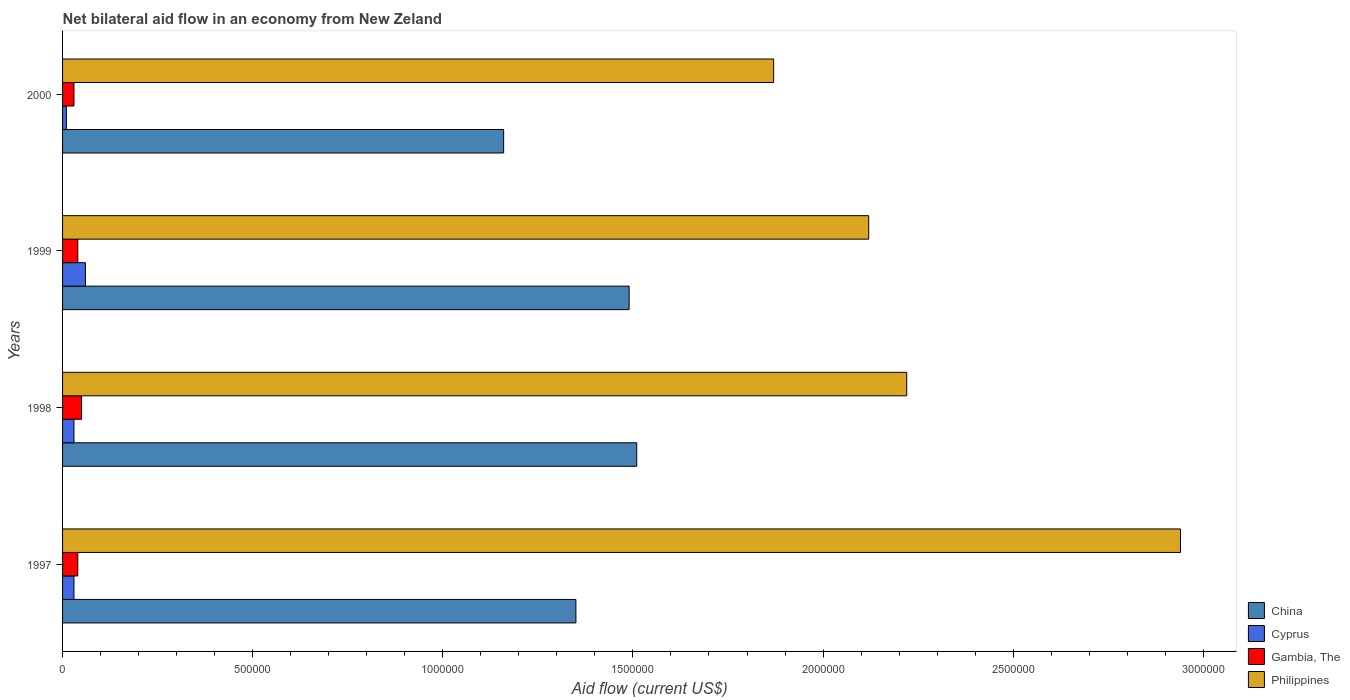How many different coloured bars are there?
Provide a short and direct response. 4. Are the number of bars per tick equal to the number of legend labels?
Your response must be concise. Yes. How many bars are there on the 1st tick from the bottom?
Make the answer very short. 4. What is the net bilateral aid flow in Philippines in 1997?
Keep it short and to the point. 2.94e+06. Across all years, what is the maximum net bilateral aid flow in China?
Offer a very short reply. 1.51e+06. In which year was the net bilateral aid flow in Philippines maximum?
Offer a terse response. 1997. What is the total net bilateral aid flow in China in the graph?
Keep it short and to the point. 5.51e+06. What is the difference between the net bilateral aid flow in Cyprus in 1997 and that in 1998?
Keep it short and to the point. 0. What is the difference between the net bilateral aid flow in China in 1998 and the net bilateral aid flow in Philippines in 1999?
Provide a succinct answer. -6.10e+05. What is the average net bilateral aid flow in Cyprus per year?
Ensure brevity in your answer.  3.25e+04. In the year 1998, what is the difference between the net bilateral aid flow in China and net bilateral aid flow in Gambia, The?
Your answer should be compact. 1.46e+06. What is the ratio of the net bilateral aid flow in Philippines in 1997 to that in 1998?
Offer a terse response. 1.32. Is the net bilateral aid flow in China in 1997 less than that in 1999?
Offer a very short reply. Yes. What is the difference between the highest and the second highest net bilateral aid flow in Gambia, The?
Ensure brevity in your answer.  10000. Is it the case that in every year, the sum of the net bilateral aid flow in Philippines and net bilateral aid flow in China is greater than the sum of net bilateral aid flow in Gambia, The and net bilateral aid flow in Cyprus?
Provide a succinct answer. Yes. What does the 4th bar from the bottom in 1999 represents?
Offer a terse response. Philippines. How many bars are there?
Offer a terse response. 16. How many years are there in the graph?
Your answer should be very brief. 4. Does the graph contain any zero values?
Provide a short and direct response. No. How many legend labels are there?
Provide a succinct answer. 4. What is the title of the graph?
Provide a short and direct response. Net bilateral aid flow in an economy from New Zeland. Does "Ethiopia" appear as one of the legend labels in the graph?
Offer a very short reply. No. What is the label or title of the X-axis?
Ensure brevity in your answer.  Aid flow (current US$). What is the label or title of the Y-axis?
Provide a succinct answer. Years. What is the Aid flow (current US$) of China in 1997?
Offer a very short reply. 1.35e+06. What is the Aid flow (current US$) in Cyprus in 1997?
Ensure brevity in your answer.  3.00e+04. What is the Aid flow (current US$) of Gambia, The in 1997?
Your answer should be very brief. 4.00e+04. What is the Aid flow (current US$) in Philippines in 1997?
Offer a very short reply. 2.94e+06. What is the Aid flow (current US$) in China in 1998?
Provide a succinct answer. 1.51e+06. What is the Aid flow (current US$) in Cyprus in 1998?
Your answer should be very brief. 3.00e+04. What is the Aid flow (current US$) of Philippines in 1998?
Provide a short and direct response. 2.22e+06. What is the Aid flow (current US$) of China in 1999?
Ensure brevity in your answer.  1.49e+06. What is the Aid flow (current US$) in Cyprus in 1999?
Your response must be concise. 6.00e+04. What is the Aid flow (current US$) in Gambia, The in 1999?
Make the answer very short. 4.00e+04. What is the Aid flow (current US$) in Philippines in 1999?
Provide a succinct answer. 2.12e+06. What is the Aid flow (current US$) in China in 2000?
Offer a terse response. 1.16e+06. What is the Aid flow (current US$) of Gambia, The in 2000?
Ensure brevity in your answer.  3.00e+04. What is the Aid flow (current US$) of Philippines in 2000?
Offer a terse response. 1.87e+06. Across all years, what is the maximum Aid flow (current US$) of China?
Make the answer very short. 1.51e+06. Across all years, what is the maximum Aid flow (current US$) of Gambia, The?
Your response must be concise. 5.00e+04. Across all years, what is the maximum Aid flow (current US$) in Philippines?
Your response must be concise. 2.94e+06. Across all years, what is the minimum Aid flow (current US$) of China?
Keep it short and to the point. 1.16e+06. Across all years, what is the minimum Aid flow (current US$) of Cyprus?
Offer a very short reply. 10000. Across all years, what is the minimum Aid flow (current US$) in Philippines?
Provide a succinct answer. 1.87e+06. What is the total Aid flow (current US$) in China in the graph?
Provide a short and direct response. 5.51e+06. What is the total Aid flow (current US$) in Cyprus in the graph?
Make the answer very short. 1.30e+05. What is the total Aid flow (current US$) of Philippines in the graph?
Offer a terse response. 9.15e+06. What is the difference between the Aid flow (current US$) in China in 1997 and that in 1998?
Offer a very short reply. -1.60e+05. What is the difference between the Aid flow (current US$) of Philippines in 1997 and that in 1998?
Offer a very short reply. 7.20e+05. What is the difference between the Aid flow (current US$) of Gambia, The in 1997 and that in 1999?
Give a very brief answer. 0. What is the difference between the Aid flow (current US$) of Philippines in 1997 and that in 1999?
Make the answer very short. 8.20e+05. What is the difference between the Aid flow (current US$) of Gambia, The in 1997 and that in 2000?
Offer a terse response. 10000. What is the difference between the Aid flow (current US$) of Philippines in 1997 and that in 2000?
Make the answer very short. 1.07e+06. What is the difference between the Aid flow (current US$) in Gambia, The in 1998 and that in 1999?
Give a very brief answer. 10000. What is the difference between the Aid flow (current US$) in Philippines in 1998 and that in 1999?
Give a very brief answer. 1.00e+05. What is the difference between the Aid flow (current US$) in China in 1998 and that in 2000?
Provide a short and direct response. 3.50e+05. What is the difference between the Aid flow (current US$) of China in 1999 and that in 2000?
Your response must be concise. 3.30e+05. What is the difference between the Aid flow (current US$) of Gambia, The in 1999 and that in 2000?
Make the answer very short. 10000. What is the difference between the Aid flow (current US$) of China in 1997 and the Aid flow (current US$) of Cyprus in 1998?
Make the answer very short. 1.32e+06. What is the difference between the Aid flow (current US$) in China in 1997 and the Aid flow (current US$) in Gambia, The in 1998?
Offer a terse response. 1.30e+06. What is the difference between the Aid flow (current US$) in China in 1997 and the Aid flow (current US$) in Philippines in 1998?
Provide a succinct answer. -8.70e+05. What is the difference between the Aid flow (current US$) of Cyprus in 1997 and the Aid flow (current US$) of Philippines in 1998?
Your answer should be compact. -2.19e+06. What is the difference between the Aid flow (current US$) in Gambia, The in 1997 and the Aid flow (current US$) in Philippines in 1998?
Keep it short and to the point. -2.18e+06. What is the difference between the Aid flow (current US$) of China in 1997 and the Aid flow (current US$) of Cyprus in 1999?
Offer a very short reply. 1.29e+06. What is the difference between the Aid flow (current US$) in China in 1997 and the Aid flow (current US$) in Gambia, The in 1999?
Make the answer very short. 1.31e+06. What is the difference between the Aid flow (current US$) in China in 1997 and the Aid flow (current US$) in Philippines in 1999?
Offer a very short reply. -7.70e+05. What is the difference between the Aid flow (current US$) in Cyprus in 1997 and the Aid flow (current US$) in Philippines in 1999?
Offer a terse response. -2.09e+06. What is the difference between the Aid flow (current US$) of Gambia, The in 1997 and the Aid flow (current US$) of Philippines in 1999?
Offer a very short reply. -2.08e+06. What is the difference between the Aid flow (current US$) in China in 1997 and the Aid flow (current US$) in Cyprus in 2000?
Give a very brief answer. 1.34e+06. What is the difference between the Aid flow (current US$) of China in 1997 and the Aid flow (current US$) of Gambia, The in 2000?
Offer a very short reply. 1.32e+06. What is the difference between the Aid flow (current US$) of China in 1997 and the Aid flow (current US$) of Philippines in 2000?
Make the answer very short. -5.20e+05. What is the difference between the Aid flow (current US$) of Cyprus in 1997 and the Aid flow (current US$) of Gambia, The in 2000?
Offer a terse response. 0. What is the difference between the Aid flow (current US$) in Cyprus in 1997 and the Aid flow (current US$) in Philippines in 2000?
Your answer should be very brief. -1.84e+06. What is the difference between the Aid flow (current US$) of Gambia, The in 1997 and the Aid flow (current US$) of Philippines in 2000?
Your response must be concise. -1.83e+06. What is the difference between the Aid flow (current US$) of China in 1998 and the Aid flow (current US$) of Cyprus in 1999?
Provide a short and direct response. 1.45e+06. What is the difference between the Aid flow (current US$) in China in 1998 and the Aid flow (current US$) in Gambia, The in 1999?
Offer a terse response. 1.47e+06. What is the difference between the Aid flow (current US$) of China in 1998 and the Aid flow (current US$) of Philippines in 1999?
Your answer should be very brief. -6.10e+05. What is the difference between the Aid flow (current US$) in Cyprus in 1998 and the Aid flow (current US$) in Philippines in 1999?
Provide a short and direct response. -2.09e+06. What is the difference between the Aid flow (current US$) of Gambia, The in 1998 and the Aid flow (current US$) of Philippines in 1999?
Ensure brevity in your answer.  -2.07e+06. What is the difference between the Aid flow (current US$) of China in 1998 and the Aid flow (current US$) of Cyprus in 2000?
Offer a terse response. 1.50e+06. What is the difference between the Aid flow (current US$) of China in 1998 and the Aid flow (current US$) of Gambia, The in 2000?
Ensure brevity in your answer.  1.48e+06. What is the difference between the Aid flow (current US$) in China in 1998 and the Aid flow (current US$) in Philippines in 2000?
Your answer should be very brief. -3.60e+05. What is the difference between the Aid flow (current US$) in Cyprus in 1998 and the Aid flow (current US$) in Gambia, The in 2000?
Your answer should be very brief. 0. What is the difference between the Aid flow (current US$) in Cyprus in 1998 and the Aid flow (current US$) in Philippines in 2000?
Keep it short and to the point. -1.84e+06. What is the difference between the Aid flow (current US$) in Gambia, The in 1998 and the Aid flow (current US$) in Philippines in 2000?
Your response must be concise. -1.82e+06. What is the difference between the Aid flow (current US$) of China in 1999 and the Aid flow (current US$) of Cyprus in 2000?
Provide a short and direct response. 1.48e+06. What is the difference between the Aid flow (current US$) of China in 1999 and the Aid flow (current US$) of Gambia, The in 2000?
Make the answer very short. 1.46e+06. What is the difference between the Aid flow (current US$) of China in 1999 and the Aid flow (current US$) of Philippines in 2000?
Your answer should be compact. -3.80e+05. What is the difference between the Aid flow (current US$) of Cyprus in 1999 and the Aid flow (current US$) of Philippines in 2000?
Offer a very short reply. -1.81e+06. What is the difference between the Aid flow (current US$) in Gambia, The in 1999 and the Aid flow (current US$) in Philippines in 2000?
Your answer should be very brief. -1.83e+06. What is the average Aid flow (current US$) in China per year?
Provide a short and direct response. 1.38e+06. What is the average Aid flow (current US$) in Cyprus per year?
Ensure brevity in your answer.  3.25e+04. What is the average Aid flow (current US$) in Gambia, The per year?
Give a very brief answer. 4.00e+04. What is the average Aid flow (current US$) in Philippines per year?
Make the answer very short. 2.29e+06. In the year 1997, what is the difference between the Aid flow (current US$) in China and Aid flow (current US$) in Cyprus?
Provide a succinct answer. 1.32e+06. In the year 1997, what is the difference between the Aid flow (current US$) of China and Aid flow (current US$) of Gambia, The?
Your answer should be compact. 1.31e+06. In the year 1997, what is the difference between the Aid flow (current US$) of China and Aid flow (current US$) of Philippines?
Ensure brevity in your answer.  -1.59e+06. In the year 1997, what is the difference between the Aid flow (current US$) in Cyprus and Aid flow (current US$) in Gambia, The?
Keep it short and to the point. -10000. In the year 1997, what is the difference between the Aid flow (current US$) in Cyprus and Aid flow (current US$) in Philippines?
Your response must be concise. -2.91e+06. In the year 1997, what is the difference between the Aid flow (current US$) in Gambia, The and Aid flow (current US$) in Philippines?
Make the answer very short. -2.90e+06. In the year 1998, what is the difference between the Aid flow (current US$) in China and Aid flow (current US$) in Cyprus?
Make the answer very short. 1.48e+06. In the year 1998, what is the difference between the Aid flow (current US$) of China and Aid flow (current US$) of Gambia, The?
Provide a short and direct response. 1.46e+06. In the year 1998, what is the difference between the Aid flow (current US$) of China and Aid flow (current US$) of Philippines?
Give a very brief answer. -7.10e+05. In the year 1998, what is the difference between the Aid flow (current US$) in Cyprus and Aid flow (current US$) in Gambia, The?
Your response must be concise. -2.00e+04. In the year 1998, what is the difference between the Aid flow (current US$) of Cyprus and Aid flow (current US$) of Philippines?
Keep it short and to the point. -2.19e+06. In the year 1998, what is the difference between the Aid flow (current US$) of Gambia, The and Aid flow (current US$) of Philippines?
Provide a succinct answer. -2.17e+06. In the year 1999, what is the difference between the Aid flow (current US$) in China and Aid flow (current US$) in Cyprus?
Provide a short and direct response. 1.43e+06. In the year 1999, what is the difference between the Aid flow (current US$) of China and Aid flow (current US$) of Gambia, The?
Ensure brevity in your answer.  1.45e+06. In the year 1999, what is the difference between the Aid flow (current US$) in China and Aid flow (current US$) in Philippines?
Provide a succinct answer. -6.30e+05. In the year 1999, what is the difference between the Aid flow (current US$) of Cyprus and Aid flow (current US$) of Gambia, The?
Provide a succinct answer. 2.00e+04. In the year 1999, what is the difference between the Aid flow (current US$) in Cyprus and Aid flow (current US$) in Philippines?
Your response must be concise. -2.06e+06. In the year 1999, what is the difference between the Aid flow (current US$) in Gambia, The and Aid flow (current US$) in Philippines?
Keep it short and to the point. -2.08e+06. In the year 2000, what is the difference between the Aid flow (current US$) of China and Aid flow (current US$) of Cyprus?
Your response must be concise. 1.15e+06. In the year 2000, what is the difference between the Aid flow (current US$) in China and Aid flow (current US$) in Gambia, The?
Your answer should be compact. 1.13e+06. In the year 2000, what is the difference between the Aid flow (current US$) of China and Aid flow (current US$) of Philippines?
Offer a very short reply. -7.10e+05. In the year 2000, what is the difference between the Aid flow (current US$) of Cyprus and Aid flow (current US$) of Gambia, The?
Keep it short and to the point. -2.00e+04. In the year 2000, what is the difference between the Aid flow (current US$) in Cyprus and Aid flow (current US$) in Philippines?
Your answer should be very brief. -1.86e+06. In the year 2000, what is the difference between the Aid flow (current US$) of Gambia, The and Aid flow (current US$) of Philippines?
Your response must be concise. -1.84e+06. What is the ratio of the Aid flow (current US$) in China in 1997 to that in 1998?
Keep it short and to the point. 0.89. What is the ratio of the Aid flow (current US$) in Cyprus in 1997 to that in 1998?
Provide a short and direct response. 1. What is the ratio of the Aid flow (current US$) of Philippines in 1997 to that in 1998?
Ensure brevity in your answer.  1.32. What is the ratio of the Aid flow (current US$) of China in 1997 to that in 1999?
Provide a succinct answer. 0.91. What is the ratio of the Aid flow (current US$) in Gambia, The in 1997 to that in 1999?
Make the answer very short. 1. What is the ratio of the Aid flow (current US$) of Philippines in 1997 to that in 1999?
Provide a short and direct response. 1.39. What is the ratio of the Aid flow (current US$) in China in 1997 to that in 2000?
Offer a very short reply. 1.16. What is the ratio of the Aid flow (current US$) in Cyprus in 1997 to that in 2000?
Your response must be concise. 3. What is the ratio of the Aid flow (current US$) of Philippines in 1997 to that in 2000?
Provide a short and direct response. 1.57. What is the ratio of the Aid flow (current US$) in China in 1998 to that in 1999?
Your answer should be very brief. 1.01. What is the ratio of the Aid flow (current US$) in Cyprus in 1998 to that in 1999?
Provide a succinct answer. 0.5. What is the ratio of the Aid flow (current US$) of Gambia, The in 1998 to that in 1999?
Provide a short and direct response. 1.25. What is the ratio of the Aid flow (current US$) in Philippines in 1998 to that in 1999?
Ensure brevity in your answer.  1.05. What is the ratio of the Aid flow (current US$) in China in 1998 to that in 2000?
Ensure brevity in your answer.  1.3. What is the ratio of the Aid flow (current US$) of Gambia, The in 1998 to that in 2000?
Provide a short and direct response. 1.67. What is the ratio of the Aid flow (current US$) in Philippines in 1998 to that in 2000?
Keep it short and to the point. 1.19. What is the ratio of the Aid flow (current US$) in China in 1999 to that in 2000?
Keep it short and to the point. 1.28. What is the ratio of the Aid flow (current US$) in Gambia, The in 1999 to that in 2000?
Ensure brevity in your answer.  1.33. What is the ratio of the Aid flow (current US$) of Philippines in 1999 to that in 2000?
Offer a very short reply. 1.13. What is the difference between the highest and the second highest Aid flow (current US$) of Gambia, The?
Provide a short and direct response. 10000. What is the difference between the highest and the second highest Aid flow (current US$) in Philippines?
Ensure brevity in your answer.  7.20e+05. What is the difference between the highest and the lowest Aid flow (current US$) of China?
Provide a succinct answer. 3.50e+05. What is the difference between the highest and the lowest Aid flow (current US$) in Cyprus?
Your answer should be very brief. 5.00e+04. What is the difference between the highest and the lowest Aid flow (current US$) of Philippines?
Your answer should be very brief. 1.07e+06. 